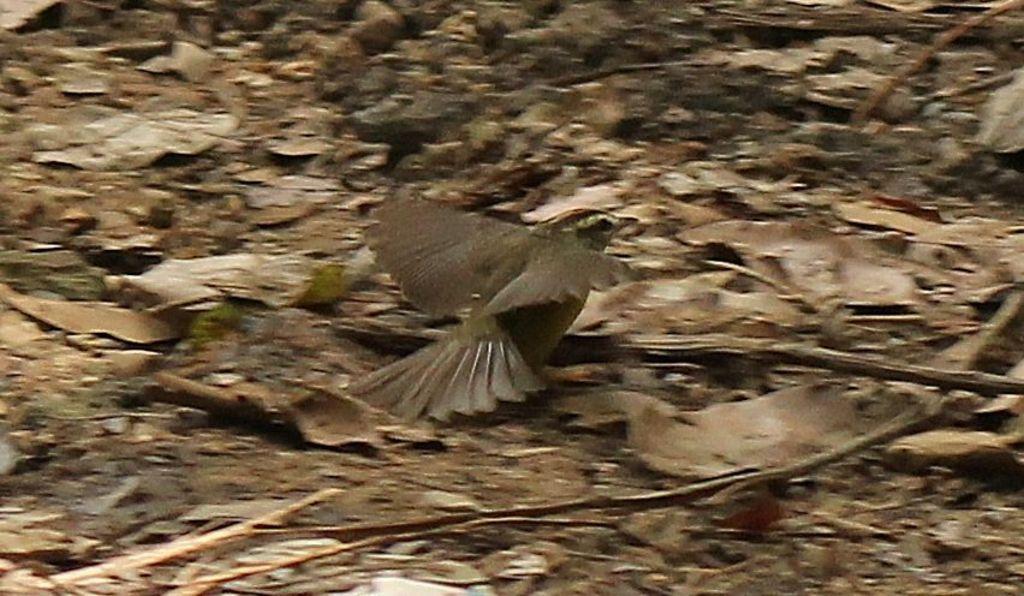Could you give a brief overview of what you see in this image? In this image I can see a bird which is in brown color and the background is also in brown color. 